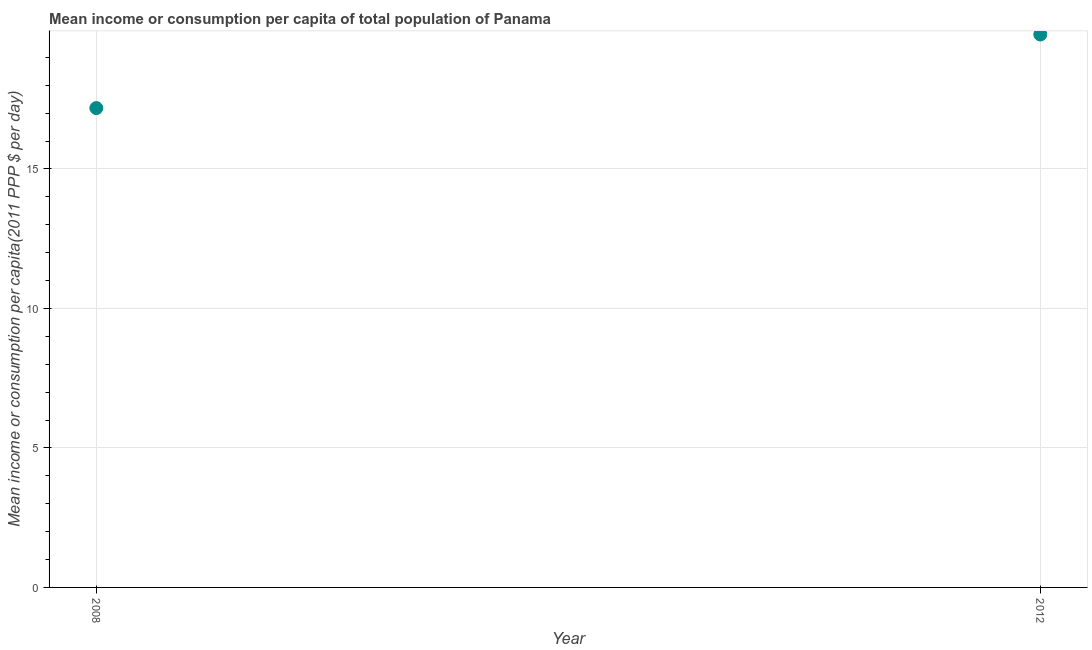What is the mean income or consumption in 2012?
Your answer should be compact. 19.82. Across all years, what is the maximum mean income or consumption?
Your answer should be very brief. 19.82. Across all years, what is the minimum mean income or consumption?
Make the answer very short. 17.18. In which year was the mean income or consumption maximum?
Your response must be concise. 2012. In which year was the mean income or consumption minimum?
Give a very brief answer. 2008. What is the sum of the mean income or consumption?
Offer a terse response. 37. What is the difference between the mean income or consumption in 2008 and 2012?
Offer a terse response. -2.64. What is the average mean income or consumption per year?
Offer a very short reply. 18.5. What is the median mean income or consumption?
Your response must be concise. 18.5. In how many years, is the mean income or consumption greater than 13 $?
Your response must be concise. 2. What is the ratio of the mean income or consumption in 2008 to that in 2012?
Provide a short and direct response. 0.87. Is the mean income or consumption in 2008 less than that in 2012?
Ensure brevity in your answer.  Yes. In how many years, is the mean income or consumption greater than the average mean income or consumption taken over all years?
Provide a succinct answer. 1. Does the mean income or consumption monotonically increase over the years?
Make the answer very short. Yes. How many years are there in the graph?
Ensure brevity in your answer.  2. What is the difference between two consecutive major ticks on the Y-axis?
Offer a very short reply. 5. Are the values on the major ticks of Y-axis written in scientific E-notation?
Your answer should be very brief. No. Does the graph contain any zero values?
Make the answer very short. No. Does the graph contain grids?
Provide a succinct answer. Yes. What is the title of the graph?
Provide a succinct answer. Mean income or consumption per capita of total population of Panama. What is the label or title of the X-axis?
Your answer should be compact. Year. What is the label or title of the Y-axis?
Provide a short and direct response. Mean income or consumption per capita(2011 PPP $ per day). What is the Mean income or consumption per capita(2011 PPP $ per day) in 2008?
Ensure brevity in your answer.  17.18. What is the Mean income or consumption per capita(2011 PPP $ per day) in 2012?
Offer a terse response. 19.82. What is the difference between the Mean income or consumption per capita(2011 PPP $ per day) in 2008 and 2012?
Make the answer very short. -2.64. What is the ratio of the Mean income or consumption per capita(2011 PPP $ per day) in 2008 to that in 2012?
Your answer should be very brief. 0.87. 